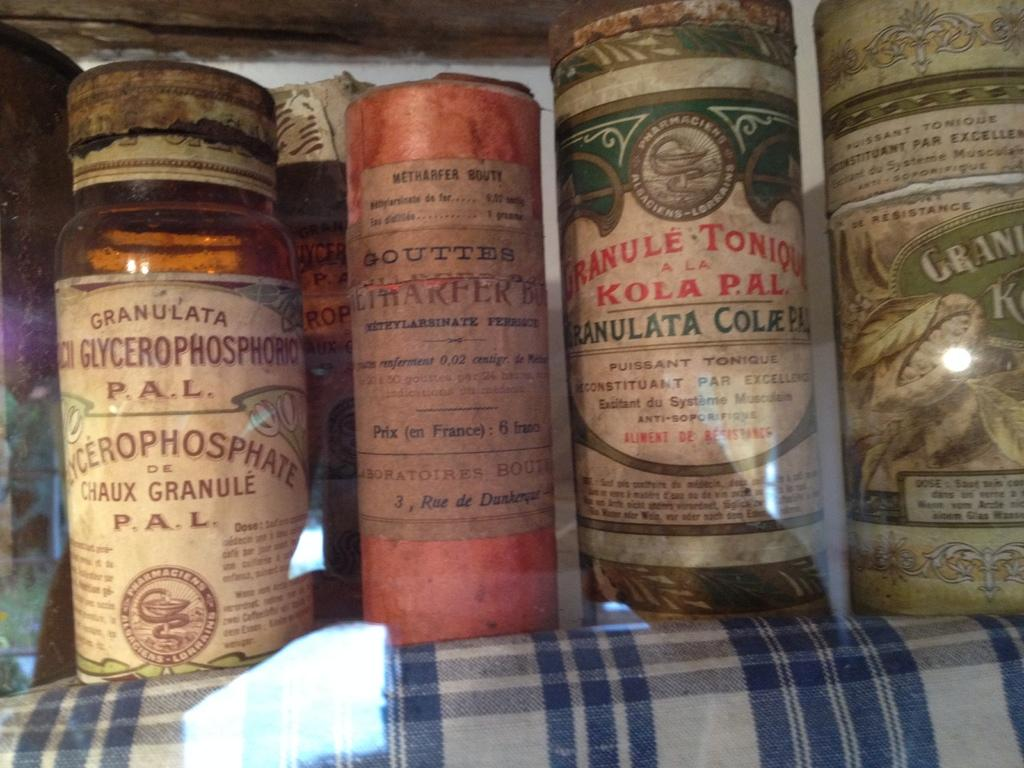<image>
Provide a brief description of the given image. a bottle of Granule next to many other ones 